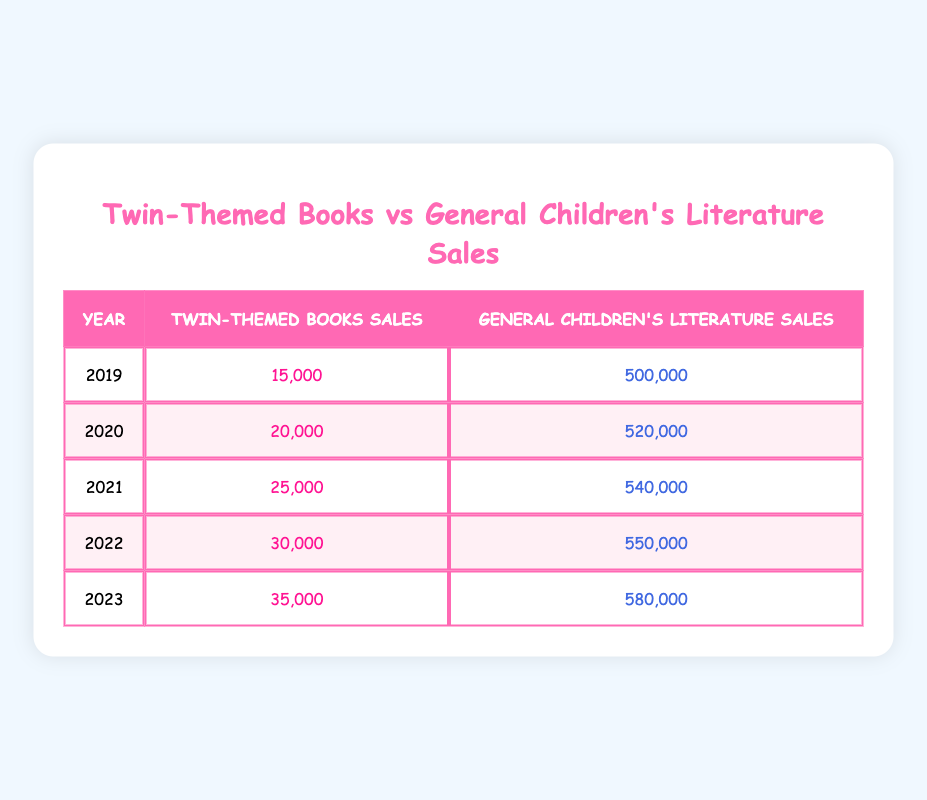What were the sales of twin-themed books in 2020? From the table, the sales of twin-themed books for the year 2020 is directly listed as 20,000.
Answer: 20,000 In which year did the sales of general children's literature reach 540,000? The sales of general children's literature for the year 2021 is listed as 540,000 in the table.
Answer: 2021 What is the total sales of twin-themed books from 2019 to 2023? To find the total sales of twin-themed books from 2019 to 2023, we add the sales for each year: 15,000 + 20,000 + 25,000 + 30,000 + 35,000 = 125,000.
Answer: 125,000 Did the sales of twin-themed books ever exceed 30,000? The data shows that twin-themed book sales reached 35,000 in 2023, exceeding 30,000.
Answer: Yes What was the average yearly sales of general children's literature from 2019 to 2023? To find the average sales, we first sum the sales from each year: 500,000 + 520,000 + 540,000 + 550,000 + 580,000 = 2,690,000. Then, divide by the number of years, which is 5: 2,690,000 / 5 = 538,000.
Answer: 538,000 What was the percentage increase in sales of twin-themed books from 2019 to 2023? The sales of twin-themed books increased from 15,000 in 2019 to 35,000 in 2023. To find the percentage increase: (35,000 - 15,000) / 15,000 * 100 = 133.33%.
Answer: 133.33% How much more did general children's literature sell compared to twin-themed books in 2021? In 2021, general children's literature sales were 540,000 and twin-themed books sales were 25,000. The difference is 540,000 - 25,000 = 515,000.
Answer: 515,000 In which year did twin-themed books see the highest sales? From the table, the highest sales for twin-themed books occurred in 2023, where sales were 35,000.
Answer: 2023 